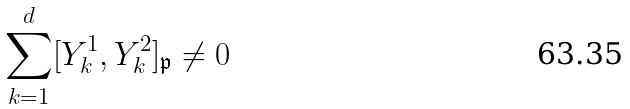<formula> <loc_0><loc_0><loc_500><loc_500>\sum _ { k = 1 } ^ { d } [ Y _ { k } ^ { 1 } , Y _ { k } ^ { 2 } ] _ { \mathfrak { p } } \neq 0</formula> 